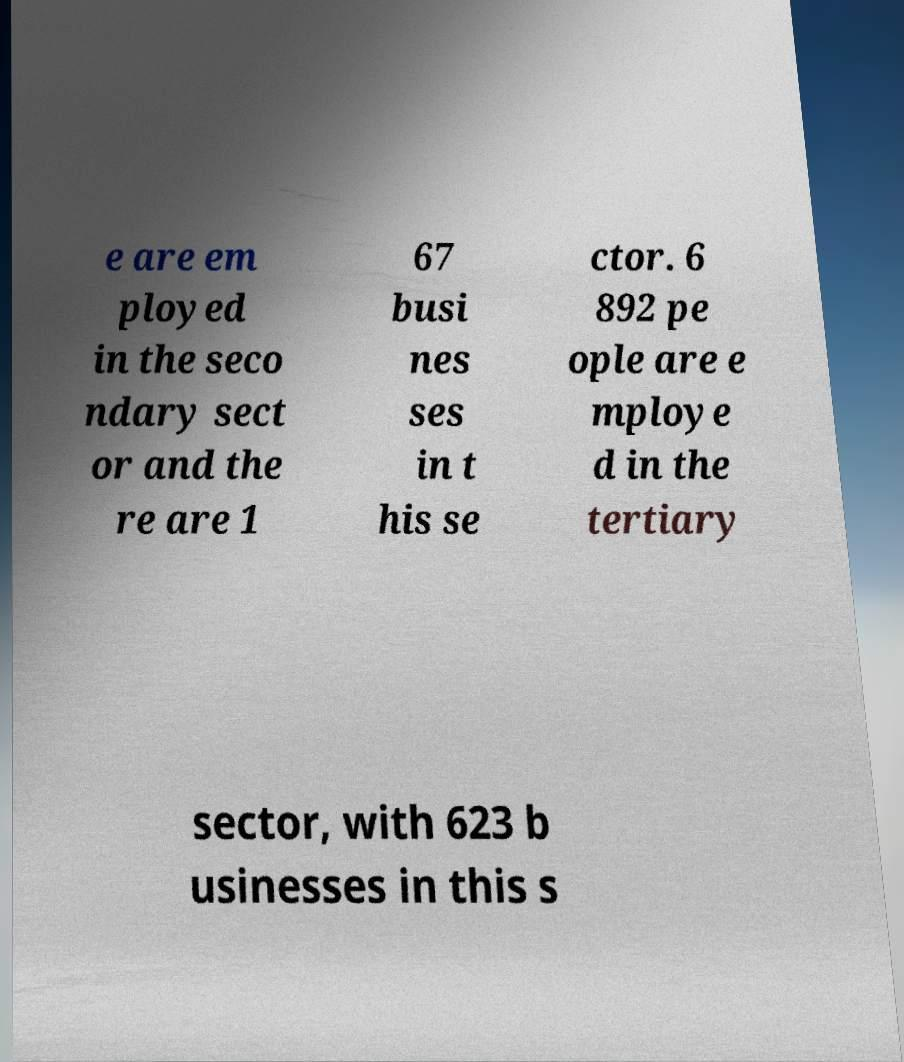Can you accurately transcribe the text from the provided image for me? e are em ployed in the seco ndary sect or and the re are 1 67 busi nes ses in t his se ctor. 6 892 pe ople are e mploye d in the tertiary sector, with 623 b usinesses in this s 